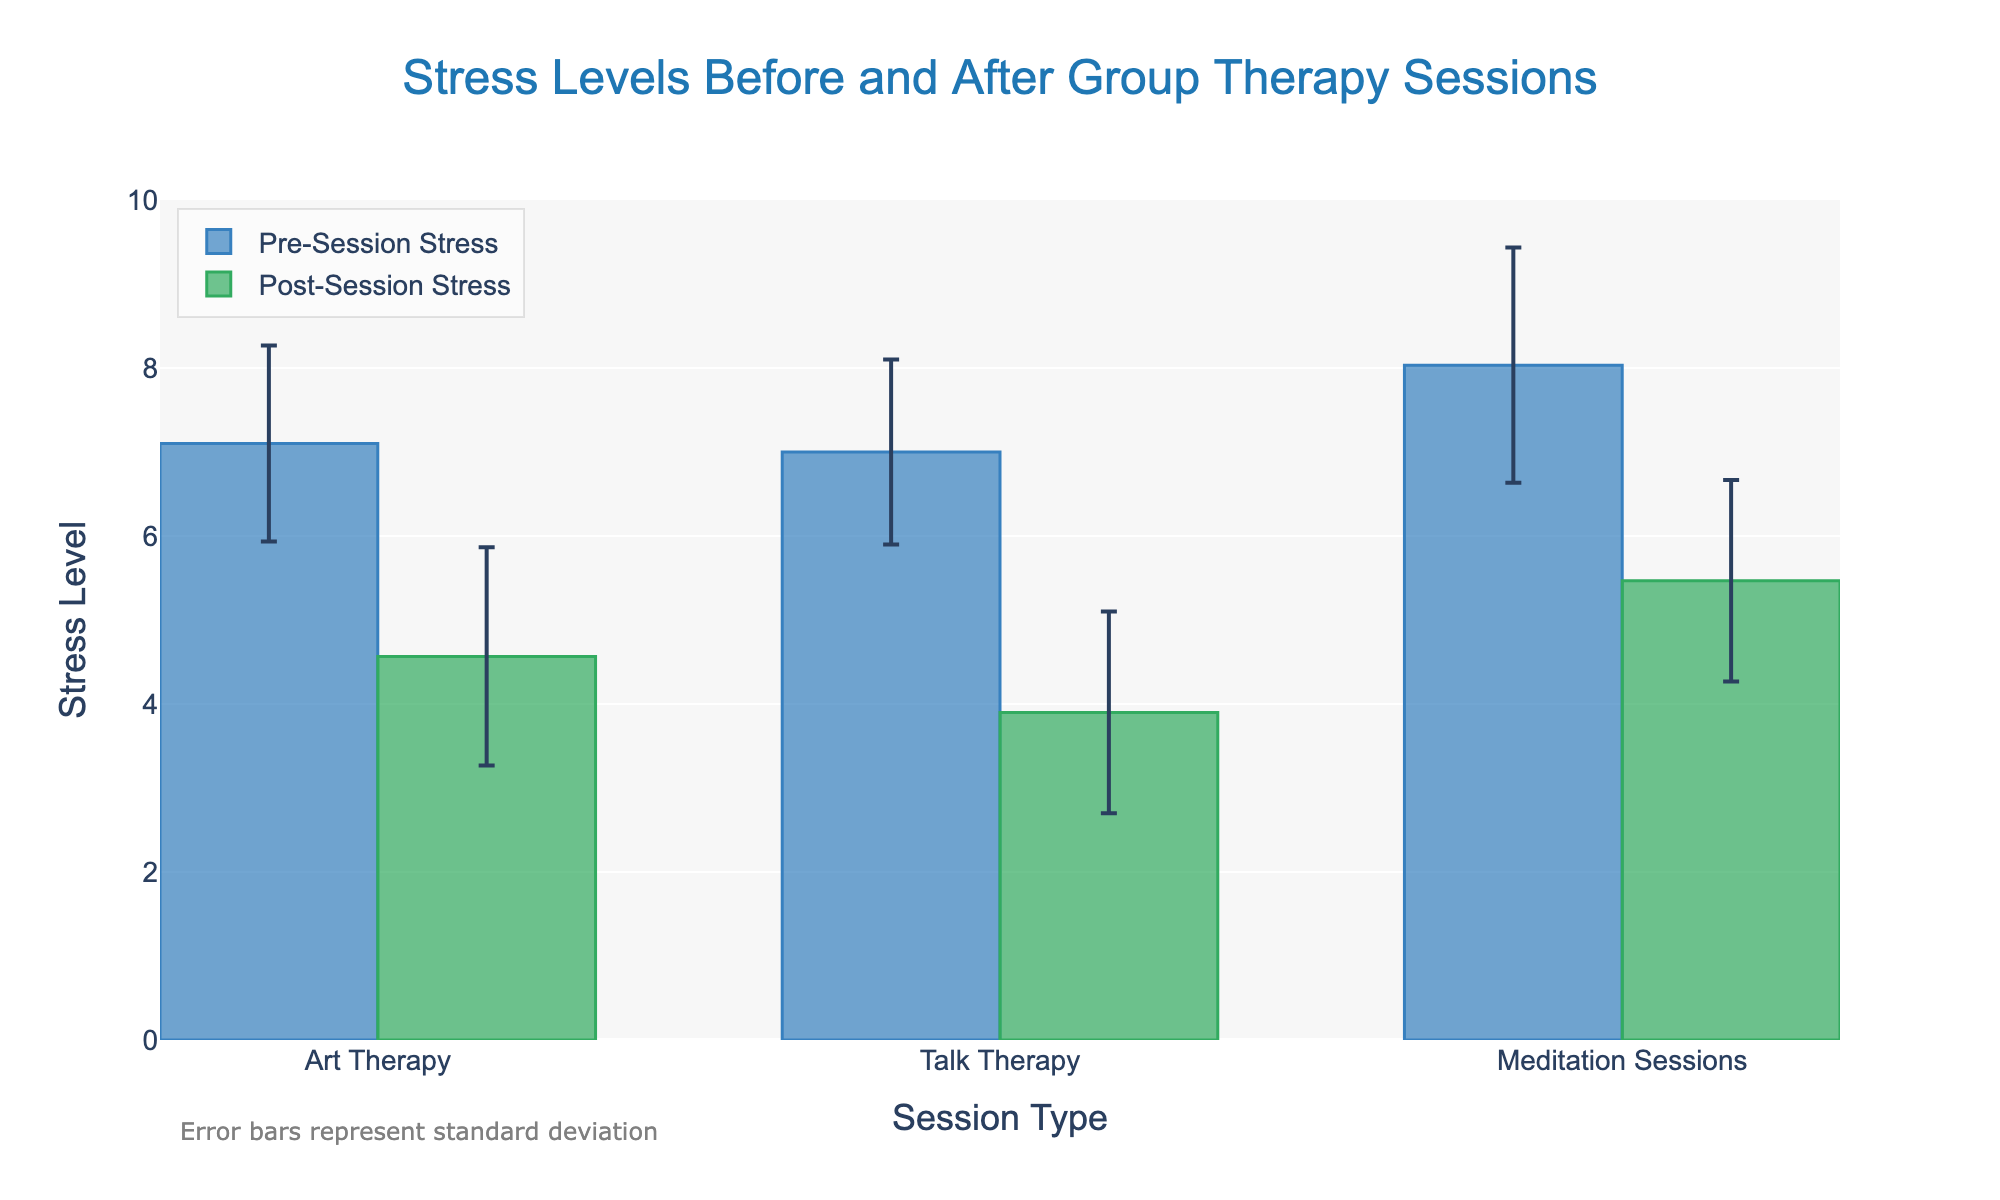What is the title of the figure? The title is located at the top center of the plot and provides the main description of the figure's content. In this case, it reads 'Stress Levels Before and After Group Therapy Sessions'.
Answer: Stress Levels Before and After Group Therapy Sessions Which session type has the highest average pre-session stress level? To find the highest average pre-session stress level, look for the tallest bar in the 'Pre-Session Stress' category. From the figure, 'Talk Therapy' has the highest pre-session stress level.
Answer: Talk Therapy What is the average post-session stress level for Art Therapy sessions? The average post-session stress level for Art Therapy can be found by identifying the height of the 'Post-Session Stress' bar corresponding to Art Therapy.
Answer: 4.57 How does the average pre-session stress level of Talk Therapy compare to its post-session level? Compare the height of the 'Pre-Session Stress' bar to the 'Post-Session Stress' bar for Talk Therapy. The pre-session level is higher than the post-session level.
Answer: Pre-session is higher Which session type shows the largest reduction in stress levels from pre- to post-session? Calculate the reduction by subtracting the average post-session stress level from the average pre-session stress level for each session type. Meditation Sessions show the largest reduction.
Answer: Meditation Sessions What are the error bars representing in the figure? The error bars show the standard deviation for each of the average stress levels, which provides an indication of the variability or spread of the data around the mean.
Answer: Standard deviation Which session type has the smallest standard deviation in pre-session stress levels? Observe the length of the error bars for pre-session stress levels. The shortest error bar indicates the smallest standard deviation. For Art Therapy, it is the smallest.
Answer: Art Therapy What is the average reduction in stress level for Meditation Sessions? To determine the average reduction, subtract the average post-session stress level from the average pre-session stress level for Meditation Sessions (7.0 - 3.9).
Answer: 3.1 Is there any session type where the post-session average stress level is higher than the pre-session average stress level? Compare pre-session and post-session average stress levels. If any post-session bar is taller than the corresponding pre-session bar, it indicates a higher post-session level. There is no such session type in this figure.
Answer: No Which session has the highest average post-session stress level, and what is that level? Identify the tallest bar in the 'Post-Session Stress' category. Talk Therapy has the highest average post-session stress level.
Answer: Talk Therapy, 5.47 